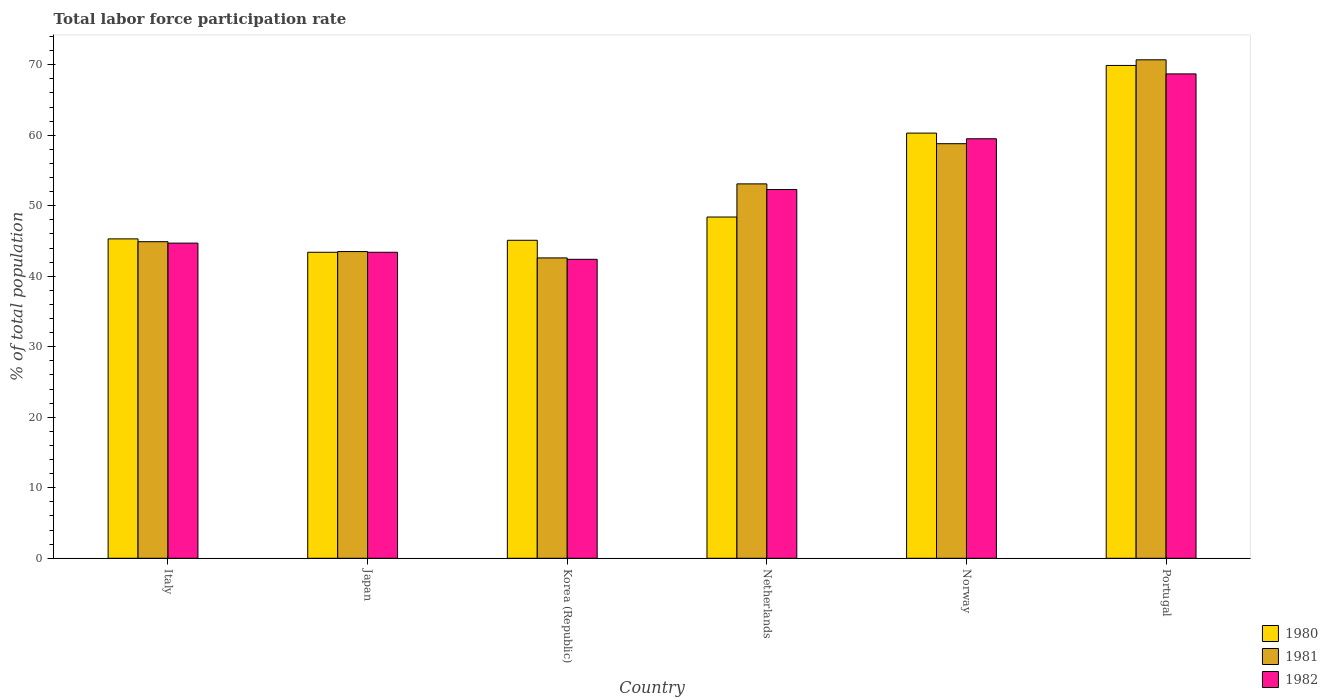How many different coloured bars are there?
Keep it short and to the point. 3. How many groups of bars are there?
Offer a terse response. 6. Are the number of bars on each tick of the X-axis equal?
Keep it short and to the point. Yes. What is the label of the 5th group of bars from the left?
Your response must be concise. Norway. In how many cases, is the number of bars for a given country not equal to the number of legend labels?
Provide a succinct answer. 0. What is the total labor force participation rate in 1980 in Norway?
Provide a succinct answer. 60.3. Across all countries, what is the maximum total labor force participation rate in 1982?
Your answer should be compact. 68.7. Across all countries, what is the minimum total labor force participation rate in 1980?
Make the answer very short. 43.4. In which country was the total labor force participation rate in 1982 maximum?
Ensure brevity in your answer.  Portugal. In which country was the total labor force participation rate in 1981 minimum?
Offer a very short reply. Korea (Republic). What is the total total labor force participation rate in 1981 in the graph?
Make the answer very short. 313.6. What is the difference between the total labor force participation rate in 1981 in Japan and that in Portugal?
Offer a very short reply. -27.2. What is the difference between the total labor force participation rate in 1980 in Japan and the total labor force participation rate in 1982 in Norway?
Provide a short and direct response. -16.1. What is the average total labor force participation rate in 1980 per country?
Keep it short and to the point. 52.07. What is the difference between the total labor force participation rate of/in 1981 and total labor force participation rate of/in 1982 in Netherlands?
Your answer should be compact. 0.8. In how many countries, is the total labor force participation rate in 1982 greater than 28 %?
Provide a succinct answer. 6. What is the ratio of the total labor force participation rate in 1980 in Italy to that in Korea (Republic)?
Your answer should be compact. 1. What is the difference between the highest and the second highest total labor force participation rate in 1980?
Your answer should be very brief. -11.9. What is the difference between the highest and the lowest total labor force participation rate in 1982?
Provide a succinct answer. 26.3. In how many countries, is the total labor force participation rate in 1980 greater than the average total labor force participation rate in 1980 taken over all countries?
Your answer should be very brief. 2. Is the sum of the total labor force participation rate in 1980 in Japan and Norway greater than the maximum total labor force participation rate in 1981 across all countries?
Give a very brief answer. Yes. Is it the case that in every country, the sum of the total labor force participation rate in 1981 and total labor force participation rate in 1982 is greater than the total labor force participation rate in 1980?
Keep it short and to the point. Yes. What is the difference between two consecutive major ticks on the Y-axis?
Offer a terse response. 10. Does the graph contain grids?
Your answer should be very brief. No. Where does the legend appear in the graph?
Your response must be concise. Bottom right. How are the legend labels stacked?
Keep it short and to the point. Vertical. What is the title of the graph?
Make the answer very short. Total labor force participation rate. What is the label or title of the X-axis?
Provide a succinct answer. Country. What is the label or title of the Y-axis?
Keep it short and to the point. % of total population. What is the % of total population of 1980 in Italy?
Ensure brevity in your answer.  45.3. What is the % of total population in 1981 in Italy?
Offer a very short reply. 44.9. What is the % of total population of 1982 in Italy?
Your answer should be compact. 44.7. What is the % of total population of 1980 in Japan?
Your answer should be compact. 43.4. What is the % of total population in 1981 in Japan?
Make the answer very short. 43.5. What is the % of total population of 1982 in Japan?
Your answer should be very brief. 43.4. What is the % of total population in 1980 in Korea (Republic)?
Offer a very short reply. 45.1. What is the % of total population in 1981 in Korea (Republic)?
Ensure brevity in your answer.  42.6. What is the % of total population in 1982 in Korea (Republic)?
Provide a succinct answer. 42.4. What is the % of total population in 1980 in Netherlands?
Your answer should be compact. 48.4. What is the % of total population of 1981 in Netherlands?
Your answer should be very brief. 53.1. What is the % of total population in 1982 in Netherlands?
Your answer should be compact. 52.3. What is the % of total population of 1980 in Norway?
Keep it short and to the point. 60.3. What is the % of total population of 1981 in Norway?
Offer a very short reply. 58.8. What is the % of total population in 1982 in Norway?
Your answer should be compact. 59.5. What is the % of total population in 1980 in Portugal?
Your answer should be very brief. 69.9. What is the % of total population of 1981 in Portugal?
Your response must be concise. 70.7. What is the % of total population in 1982 in Portugal?
Your response must be concise. 68.7. Across all countries, what is the maximum % of total population of 1980?
Provide a short and direct response. 69.9. Across all countries, what is the maximum % of total population of 1981?
Ensure brevity in your answer.  70.7. Across all countries, what is the maximum % of total population in 1982?
Provide a succinct answer. 68.7. Across all countries, what is the minimum % of total population in 1980?
Keep it short and to the point. 43.4. Across all countries, what is the minimum % of total population of 1981?
Your answer should be very brief. 42.6. Across all countries, what is the minimum % of total population in 1982?
Your answer should be compact. 42.4. What is the total % of total population of 1980 in the graph?
Provide a short and direct response. 312.4. What is the total % of total population of 1981 in the graph?
Provide a short and direct response. 313.6. What is the total % of total population in 1982 in the graph?
Give a very brief answer. 311. What is the difference between the % of total population in 1982 in Italy and that in Japan?
Ensure brevity in your answer.  1.3. What is the difference between the % of total population in 1980 in Italy and that in Korea (Republic)?
Keep it short and to the point. 0.2. What is the difference between the % of total population in 1981 in Italy and that in Korea (Republic)?
Offer a terse response. 2.3. What is the difference between the % of total population in 1982 in Italy and that in Korea (Republic)?
Offer a terse response. 2.3. What is the difference between the % of total population in 1982 in Italy and that in Netherlands?
Offer a very short reply. -7.6. What is the difference between the % of total population of 1981 in Italy and that in Norway?
Your answer should be very brief. -13.9. What is the difference between the % of total population in 1982 in Italy and that in Norway?
Give a very brief answer. -14.8. What is the difference between the % of total population of 1980 in Italy and that in Portugal?
Give a very brief answer. -24.6. What is the difference between the % of total population of 1981 in Italy and that in Portugal?
Your answer should be very brief. -25.8. What is the difference between the % of total population of 1981 in Japan and that in Korea (Republic)?
Ensure brevity in your answer.  0.9. What is the difference between the % of total population of 1982 in Japan and that in Korea (Republic)?
Your answer should be compact. 1. What is the difference between the % of total population in 1981 in Japan and that in Netherlands?
Your answer should be very brief. -9.6. What is the difference between the % of total population in 1980 in Japan and that in Norway?
Offer a very short reply. -16.9. What is the difference between the % of total population in 1981 in Japan and that in Norway?
Ensure brevity in your answer.  -15.3. What is the difference between the % of total population of 1982 in Japan and that in Norway?
Keep it short and to the point. -16.1. What is the difference between the % of total population in 1980 in Japan and that in Portugal?
Ensure brevity in your answer.  -26.5. What is the difference between the % of total population of 1981 in Japan and that in Portugal?
Give a very brief answer. -27.2. What is the difference between the % of total population in 1982 in Japan and that in Portugal?
Make the answer very short. -25.3. What is the difference between the % of total population of 1980 in Korea (Republic) and that in Netherlands?
Make the answer very short. -3.3. What is the difference between the % of total population of 1982 in Korea (Republic) and that in Netherlands?
Your response must be concise. -9.9. What is the difference between the % of total population in 1980 in Korea (Republic) and that in Norway?
Make the answer very short. -15.2. What is the difference between the % of total population of 1981 in Korea (Republic) and that in Norway?
Provide a succinct answer. -16.2. What is the difference between the % of total population in 1982 in Korea (Republic) and that in Norway?
Your response must be concise. -17.1. What is the difference between the % of total population of 1980 in Korea (Republic) and that in Portugal?
Make the answer very short. -24.8. What is the difference between the % of total population in 1981 in Korea (Republic) and that in Portugal?
Make the answer very short. -28.1. What is the difference between the % of total population of 1982 in Korea (Republic) and that in Portugal?
Offer a terse response. -26.3. What is the difference between the % of total population of 1981 in Netherlands and that in Norway?
Ensure brevity in your answer.  -5.7. What is the difference between the % of total population in 1982 in Netherlands and that in Norway?
Keep it short and to the point. -7.2. What is the difference between the % of total population of 1980 in Netherlands and that in Portugal?
Offer a terse response. -21.5. What is the difference between the % of total population in 1981 in Netherlands and that in Portugal?
Ensure brevity in your answer.  -17.6. What is the difference between the % of total population in 1982 in Netherlands and that in Portugal?
Your response must be concise. -16.4. What is the difference between the % of total population in 1981 in Norway and that in Portugal?
Your answer should be very brief. -11.9. What is the difference between the % of total population of 1980 in Italy and the % of total population of 1982 in Korea (Republic)?
Give a very brief answer. 2.9. What is the difference between the % of total population in 1981 in Italy and the % of total population in 1982 in Korea (Republic)?
Offer a terse response. 2.5. What is the difference between the % of total population in 1980 in Italy and the % of total population in 1982 in Netherlands?
Provide a short and direct response. -7. What is the difference between the % of total population of 1981 in Italy and the % of total population of 1982 in Norway?
Offer a very short reply. -14.6. What is the difference between the % of total population of 1980 in Italy and the % of total population of 1981 in Portugal?
Offer a very short reply. -25.4. What is the difference between the % of total population of 1980 in Italy and the % of total population of 1982 in Portugal?
Offer a very short reply. -23.4. What is the difference between the % of total population of 1981 in Italy and the % of total population of 1982 in Portugal?
Keep it short and to the point. -23.8. What is the difference between the % of total population in 1980 in Japan and the % of total population in 1981 in Korea (Republic)?
Your answer should be very brief. 0.8. What is the difference between the % of total population in 1980 in Japan and the % of total population in 1981 in Netherlands?
Offer a very short reply. -9.7. What is the difference between the % of total population of 1980 in Japan and the % of total population of 1982 in Netherlands?
Keep it short and to the point. -8.9. What is the difference between the % of total population of 1980 in Japan and the % of total population of 1981 in Norway?
Offer a very short reply. -15.4. What is the difference between the % of total population of 1980 in Japan and the % of total population of 1982 in Norway?
Ensure brevity in your answer.  -16.1. What is the difference between the % of total population in 1980 in Japan and the % of total population in 1981 in Portugal?
Provide a short and direct response. -27.3. What is the difference between the % of total population in 1980 in Japan and the % of total population in 1982 in Portugal?
Keep it short and to the point. -25.3. What is the difference between the % of total population in 1981 in Japan and the % of total population in 1982 in Portugal?
Offer a terse response. -25.2. What is the difference between the % of total population in 1980 in Korea (Republic) and the % of total population in 1981 in Netherlands?
Keep it short and to the point. -8. What is the difference between the % of total population of 1980 in Korea (Republic) and the % of total population of 1982 in Netherlands?
Offer a terse response. -7.2. What is the difference between the % of total population in 1980 in Korea (Republic) and the % of total population in 1981 in Norway?
Offer a very short reply. -13.7. What is the difference between the % of total population in 1980 in Korea (Republic) and the % of total population in 1982 in Norway?
Provide a succinct answer. -14.4. What is the difference between the % of total population of 1981 in Korea (Republic) and the % of total population of 1982 in Norway?
Offer a terse response. -16.9. What is the difference between the % of total population in 1980 in Korea (Republic) and the % of total population in 1981 in Portugal?
Provide a short and direct response. -25.6. What is the difference between the % of total population in 1980 in Korea (Republic) and the % of total population in 1982 in Portugal?
Ensure brevity in your answer.  -23.6. What is the difference between the % of total population in 1981 in Korea (Republic) and the % of total population in 1982 in Portugal?
Your response must be concise. -26.1. What is the difference between the % of total population in 1980 in Netherlands and the % of total population in 1982 in Norway?
Offer a very short reply. -11.1. What is the difference between the % of total population in 1981 in Netherlands and the % of total population in 1982 in Norway?
Your answer should be very brief. -6.4. What is the difference between the % of total population of 1980 in Netherlands and the % of total population of 1981 in Portugal?
Offer a terse response. -22.3. What is the difference between the % of total population in 1980 in Netherlands and the % of total population in 1982 in Portugal?
Keep it short and to the point. -20.3. What is the difference between the % of total population of 1981 in Netherlands and the % of total population of 1982 in Portugal?
Your answer should be compact. -15.6. What is the average % of total population in 1980 per country?
Keep it short and to the point. 52.07. What is the average % of total population in 1981 per country?
Provide a short and direct response. 52.27. What is the average % of total population of 1982 per country?
Offer a terse response. 51.83. What is the difference between the % of total population in 1980 and % of total population in 1981 in Italy?
Your response must be concise. 0.4. What is the difference between the % of total population in 1981 and % of total population in 1982 in Italy?
Make the answer very short. 0.2. What is the difference between the % of total population of 1981 and % of total population of 1982 in Netherlands?
Give a very brief answer. 0.8. What is the difference between the % of total population in 1981 and % of total population in 1982 in Norway?
Provide a short and direct response. -0.7. What is the difference between the % of total population of 1981 and % of total population of 1982 in Portugal?
Your answer should be compact. 2. What is the ratio of the % of total population in 1980 in Italy to that in Japan?
Ensure brevity in your answer.  1.04. What is the ratio of the % of total population of 1981 in Italy to that in Japan?
Offer a very short reply. 1.03. What is the ratio of the % of total population in 1982 in Italy to that in Japan?
Your answer should be compact. 1.03. What is the ratio of the % of total population of 1981 in Italy to that in Korea (Republic)?
Your answer should be very brief. 1.05. What is the ratio of the % of total population of 1982 in Italy to that in Korea (Republic)?
Give a very brief answer. 1.05. What is the ratio of the % of total population in 1980 in Italy to that in Netherlands?
Ensure brevity in your answer.  0.94. What is the ratio of the % of total population of 1981 in Italy to that in Netherlands?
Give a very brief answer. 0.85. What is the ratio of the % of total population in 1982 in Italy to that in Netherlands?
Make the answer very short. 0.85. What is the ratio of the % of total population in 1980 in Italy to that in Norway?
Your answer should be very brief. 0.75. What is the ratio of the % of total population in 1981 in Italy to that in Norway?
Keep it short and to the point. 0.76. What is the ratio of the % of total population in 1982 in Italy to that in Norway?
Keep it short and to the point. 0.75. What is the ratio of the % of total population of 1980 in Italy to that in Portugal?
Offer a terse response. 0.65. What is the ratio of the % of total population of 1981 in Italy to that in Portugal?
Offer a very short reply. 0.64. What is the ratio of the % of total population of 1982 in Italy to that in Portugal?
Offer a very short reply. 0.65. What is the ratio of the % of total population in 1980 in Japan to that in Korea (Republic)?
Your response must be concise. 0.96. What is the ratio of the % of total population in 1981 in Japan to that in Korea (Republic)?
Give a very brief answer. 1.02. What is the ratio of the % of total population of 1982 in Japan to that in Korea (Republic)?
Keep it short and to the point. 1.02. What is the ratio of the % of total population of 1980 in Japan to that in Netherlands?
Provide a succinct answer. 0.9. What is the ratio of the % of total population of 1981 in Japan to that in Netherlands?
Provide a succinct answer. 0.82. What is the ratio of the % of total population in 1982 in Japan to that in Netherlands?
Ensure brevity in your answer.  0.83. What is the ratio of the % of total population in 1980 in Japan to that in Norway?
Keep it short and to the point. 0.72. What is the ratio of the % of total population in 1981 in Japan to that in Norway?
Provide a succinct answer. 0.74. What is the ratio of the % of total population in 1982 in Japan to that in Norway?
Keep it short and to the point. 0.73. What is the ratio of the % of total population of 1980 in Japan to that in Portugal?
Offer a very short reply. 0.62. What is the ratio of the % of total population in 1981 in Japan to that in Portugal?
Ensure brevity in your answer.  0.62. What is the ratio of the % of total population of 1982 in Japan to that in Portugal?
Make the answer very short. 0.63. What is the ratio of the % of total population of 1980 in Korea (Republic) to that in Netherlands?
Your answer should be very brief. 0.93. What is the ratio of the % of total population in 1981 in Korea (Republic) to that in Netherlands?
Make the answer very short. 0.8. What is the ratio of the % of total population of 1982 in Korea (Republic) to that in Netherlands?
Your answer should be compact. 0.81. What is the ratio of the % of total population in 1980 in Korea (Republic) to that in Norway?
Keep it short and to the point. 0.75. What is the ratio of the % of total population of 1981 in Korea (Republic) to that in Norway?
Give a very brief answer. 0.72. What is the ratio of the % of total population in 1982 in Korea (Republic) to that in Norway?
Your response must be concise. 0.71. What is the ratio of the % of total population in 1980 in Korea (Republic) to that in Portugal?
Provide a succinct answer. 0.65. What is the ratio of the % of total population in 1981 in Korea (Republic) to that in Portugal?
Provide a succinct answer. 0.6. What is the ratio of the % of total population of 1982 in Korea (Republic) to that in Portugal?
Your response must be concise. 0.62. What is the ratio of the % of total population of 1980 in Netherlands to that in Norway?
Keep it short and to the point. 0.8. What is the ratio of the % of total population of 1981 in Netherlands to that in Norway?
Make the answer very short. 0.9. What is the ratio of the % of total population in 1982 in Netherlands to that in Norway?
Offer a very short reply. 0.88. What is the ratio of the % of total population of 1980 in Netherlands to that in Portugal?
Provide a short and direct response. 0.69. What is the ratio of the % of total population in 1981 in Netherlands to that in Portugal?
Your answer should be very brief. 0.75. What is the ratio of the % of total population in 1982 in Netherlands to that in Portugal?
Give a very brief answer. 0.76. What is the ratio of the % of total population of 1980 in Norway to that in Portugal?
Your answer should be compact. 0.86. What is the ratio of the % of total population in 1981 in Norway to that in Portugal?
Keep it short and to the point. 0.83. What is the ratio of the % of total population of 1982 in Norway to that in Portugal?
Ensure brevity in your answer.  0.87. What is the difference between the highest and the second highest % of total population of 1981?
Provide a succinct answer. 11.9. What is the difference between the highest and the lowest % of total population of 1980?
Offer a terse response. 26.5. What is the difference between the highest and the lowest % of total population in 1981?
Your answer should be very brief. 28.1. What is the difference between the highest and the lowest % of total population of 1982?
Your answer should be very brief. 26.3. 